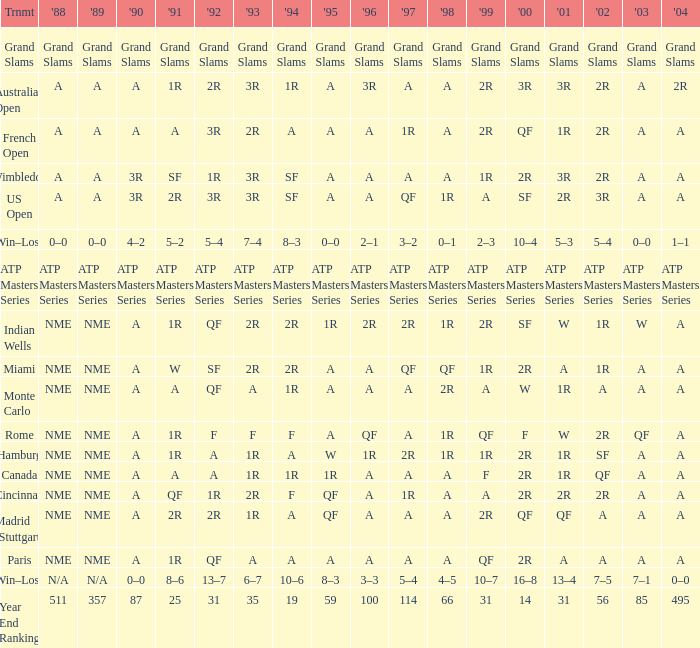What shows for 1995 when 1996 shows grand slams? Grand Slams. 